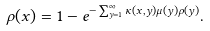Convert formula to latex. <formula><loc_0><loc_0><loc_500><loc_500>\rho ( x ) = 1 - e ^ { - \sum _ { y = 1 } ^ { \infty } \kappa ( x , y ) \mu ( y ) \rho ( y ) } .</formula> 